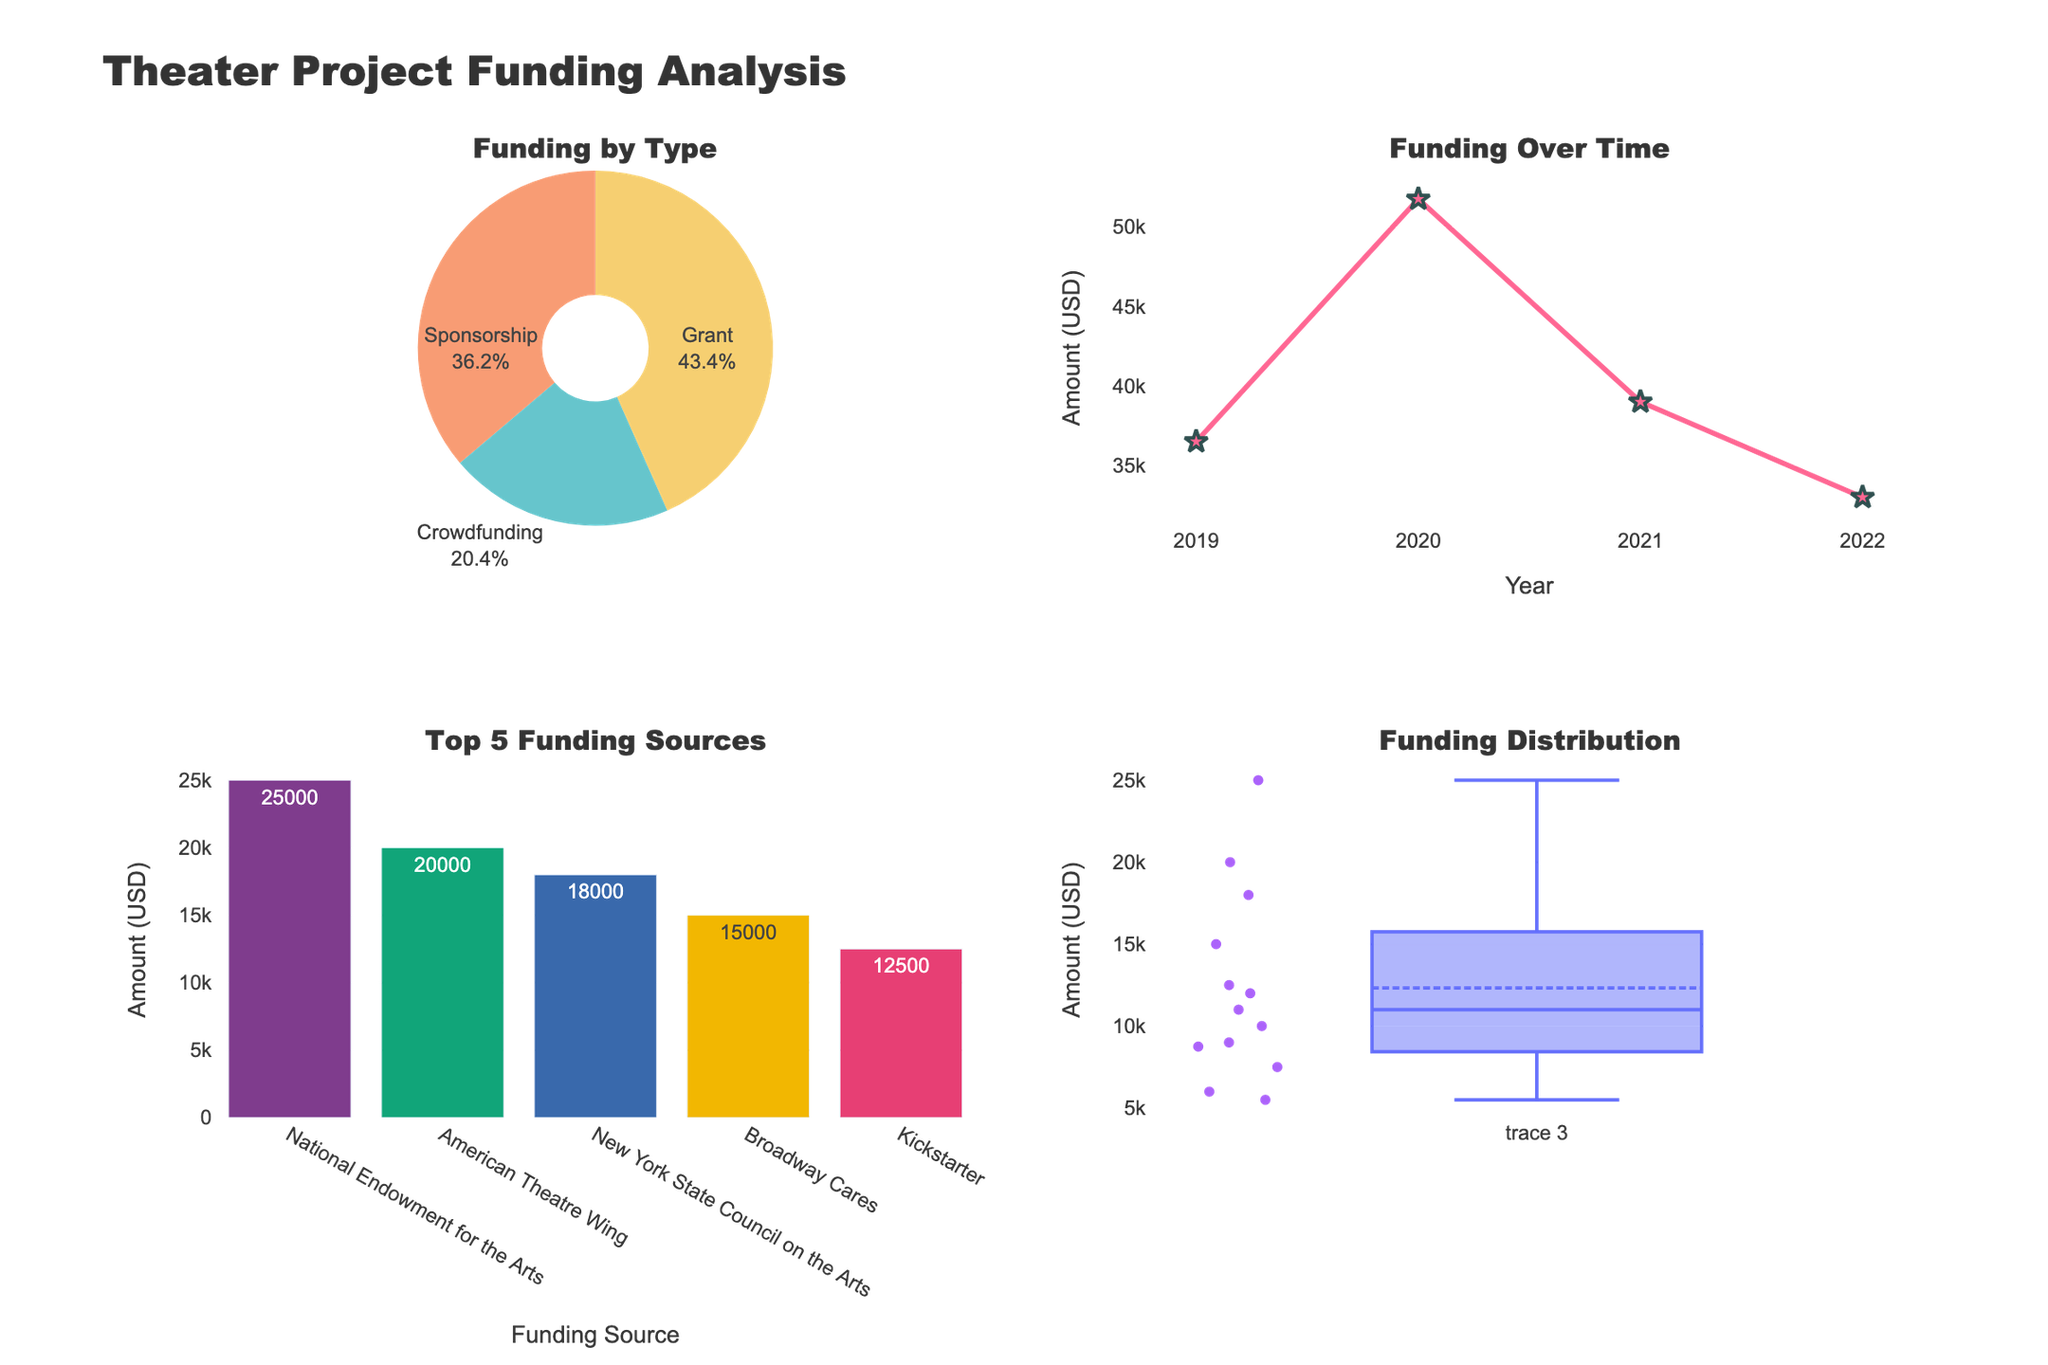What's the total amount of funding provided by grants? The pie chart shows the types of funding sources, with grants occupying a specific section. Adding up the amounts for each grant source mentioned in the data table gives the total: 25000 (National Endowment for the Arts) + 7500 (Local Arts Council) + 10000 (Dramatists Guild Foundation) + 18000 (New York State Council on the Arts) + 9000 (ArtsFund) = 69500.
Answer: 69500 Which year received the highest amount of funding? Referring to the line chart, the trend over time indicates the total funding per year. By comparing the peaks, it's evident that 2020 shows the highest point.
Answer: 2020 How many funding sources are categorized under sponsorships? The bar chart shows the top funding sources, and sponsorships can be identified by reading the data or the pie chart. By counting the sponsorship sources in the data (Broadway Cares, American Theatre Wing, Samuel French Foundation, Theatre Development Fund), we can see there are 4.
Answer: 4 What is the amount gap between the highest and the lowest funding sources among the top five? The bar chart shows the top 5 funding sources. The highest is American Theatre Wing with 20000, and the lowest in the top 5 is National Endowment for the Arts with 25000. The difference is calculated as 25000 - 12000 = 13000.
Answer: 13000 What is the range of funding amounts in the dataset? The box plot visualizes the distribution and outliers of funding amounts. By noting the maximum and minimum values (without considering outliers), the range is from 5500 to 25000. Therefore, 25000 - 5500 = 19500.
Answer: 19500 How does the total funding from crowdfunding compare to grants? The pie chart provides percentages of each type. Adding the amounts from crowdfunding and comparing it to grants from the provided data: Crowdfunding total = 12500 + 8750 + 6000 + 5500 = 32750, and as previously calculated, Grant total is 69500. Compared: 69500 > 32750.
Answer: Grants are higher What are the amounts of funding for the years 2020 and 2022, and how do they compare? Checking the line chart for specific years and reading the amounts, 2020 had the highest visible peak at 77500 and 2022 had a smaller peak at approximately 33000. The difference is 77500 - 33000 = 44500.
Answer: 2020 > 2022 by 44500 Which funding source appears most frequently in the top five, and what is the amount? Referring to the bar chart, each bar represents a unique top-five source. The highest single amount among the top five sources is American Theatre Wing with 20000.
Answer: American Theatre Wing, 20000 What's the median funding amount shown in the box plot? The box plot features a central line dividing the data into equal parts which indicates the median value. By reading from the data, more detailed investigation shows the median appears around 9500.
Answer: 9500 